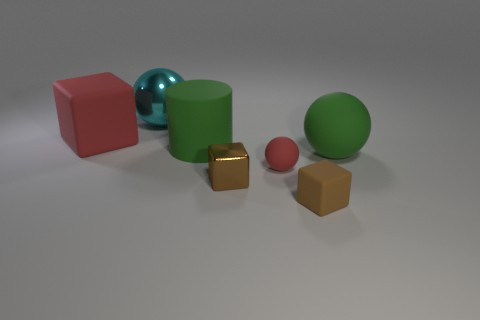Add 1 big shiny cylinders. How many objects exist? 8 Subtract all blocks. How many objects are left? 4 Add 3 large green matte cylinders. How many large green matte cylinders exist? 4 Subtract 1 red cubes. How many objects are left? 6 Subtract all large cyan balls. Subtract all small brown metal cylinders. How many objects are left? 6 Add 7 green rubber cylinders. How many green rubber cylinders are left? 8 